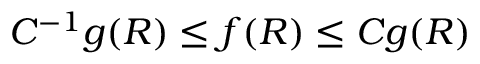Convert formula to latex. <formula><loc_0><loc_0><loc_500><loc_500>C ^ { - 1 } g ( R ) \leq f ( R ) \leq C g ( R )</formula> 